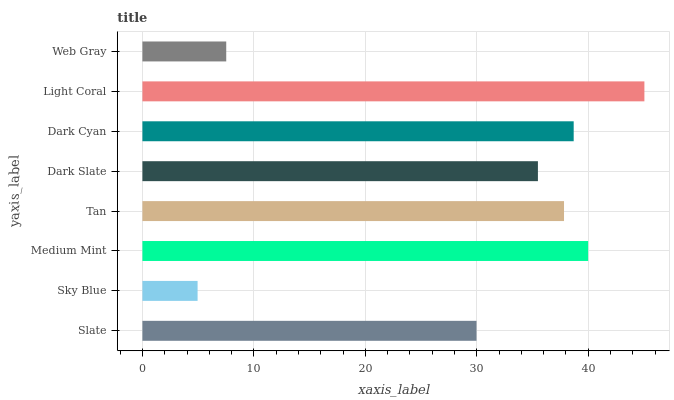Is Sky Blue the minimum?
Answer yes or no. Yes. Is Light Coral the maximum?
Answer yes or no. Yes. Is Medium Mint the minimum?
Answer yes or no. No. Is Medium Mint the maximum?
Answer yes or no. No. Is Medium Mint greater than Sky Blue?
Answer yes or no. Yes. Is Sky Blue less than Medium Mint?
Answer yes or no. Yes. Is Sky Blue greater than Medium Mint?
Answer yes or no. No. Is Medium Mint less than Sky Blue?
Answer yes or no. No. Is Tan the high median?
Answer yes or no. Yes. Is Dark Slate the low median?
Answer yes or no. Yes. Is Dark Slate the high median?
Answer yes or no. No. Is Medium Mint the low median?
Answer yes or no. No. 